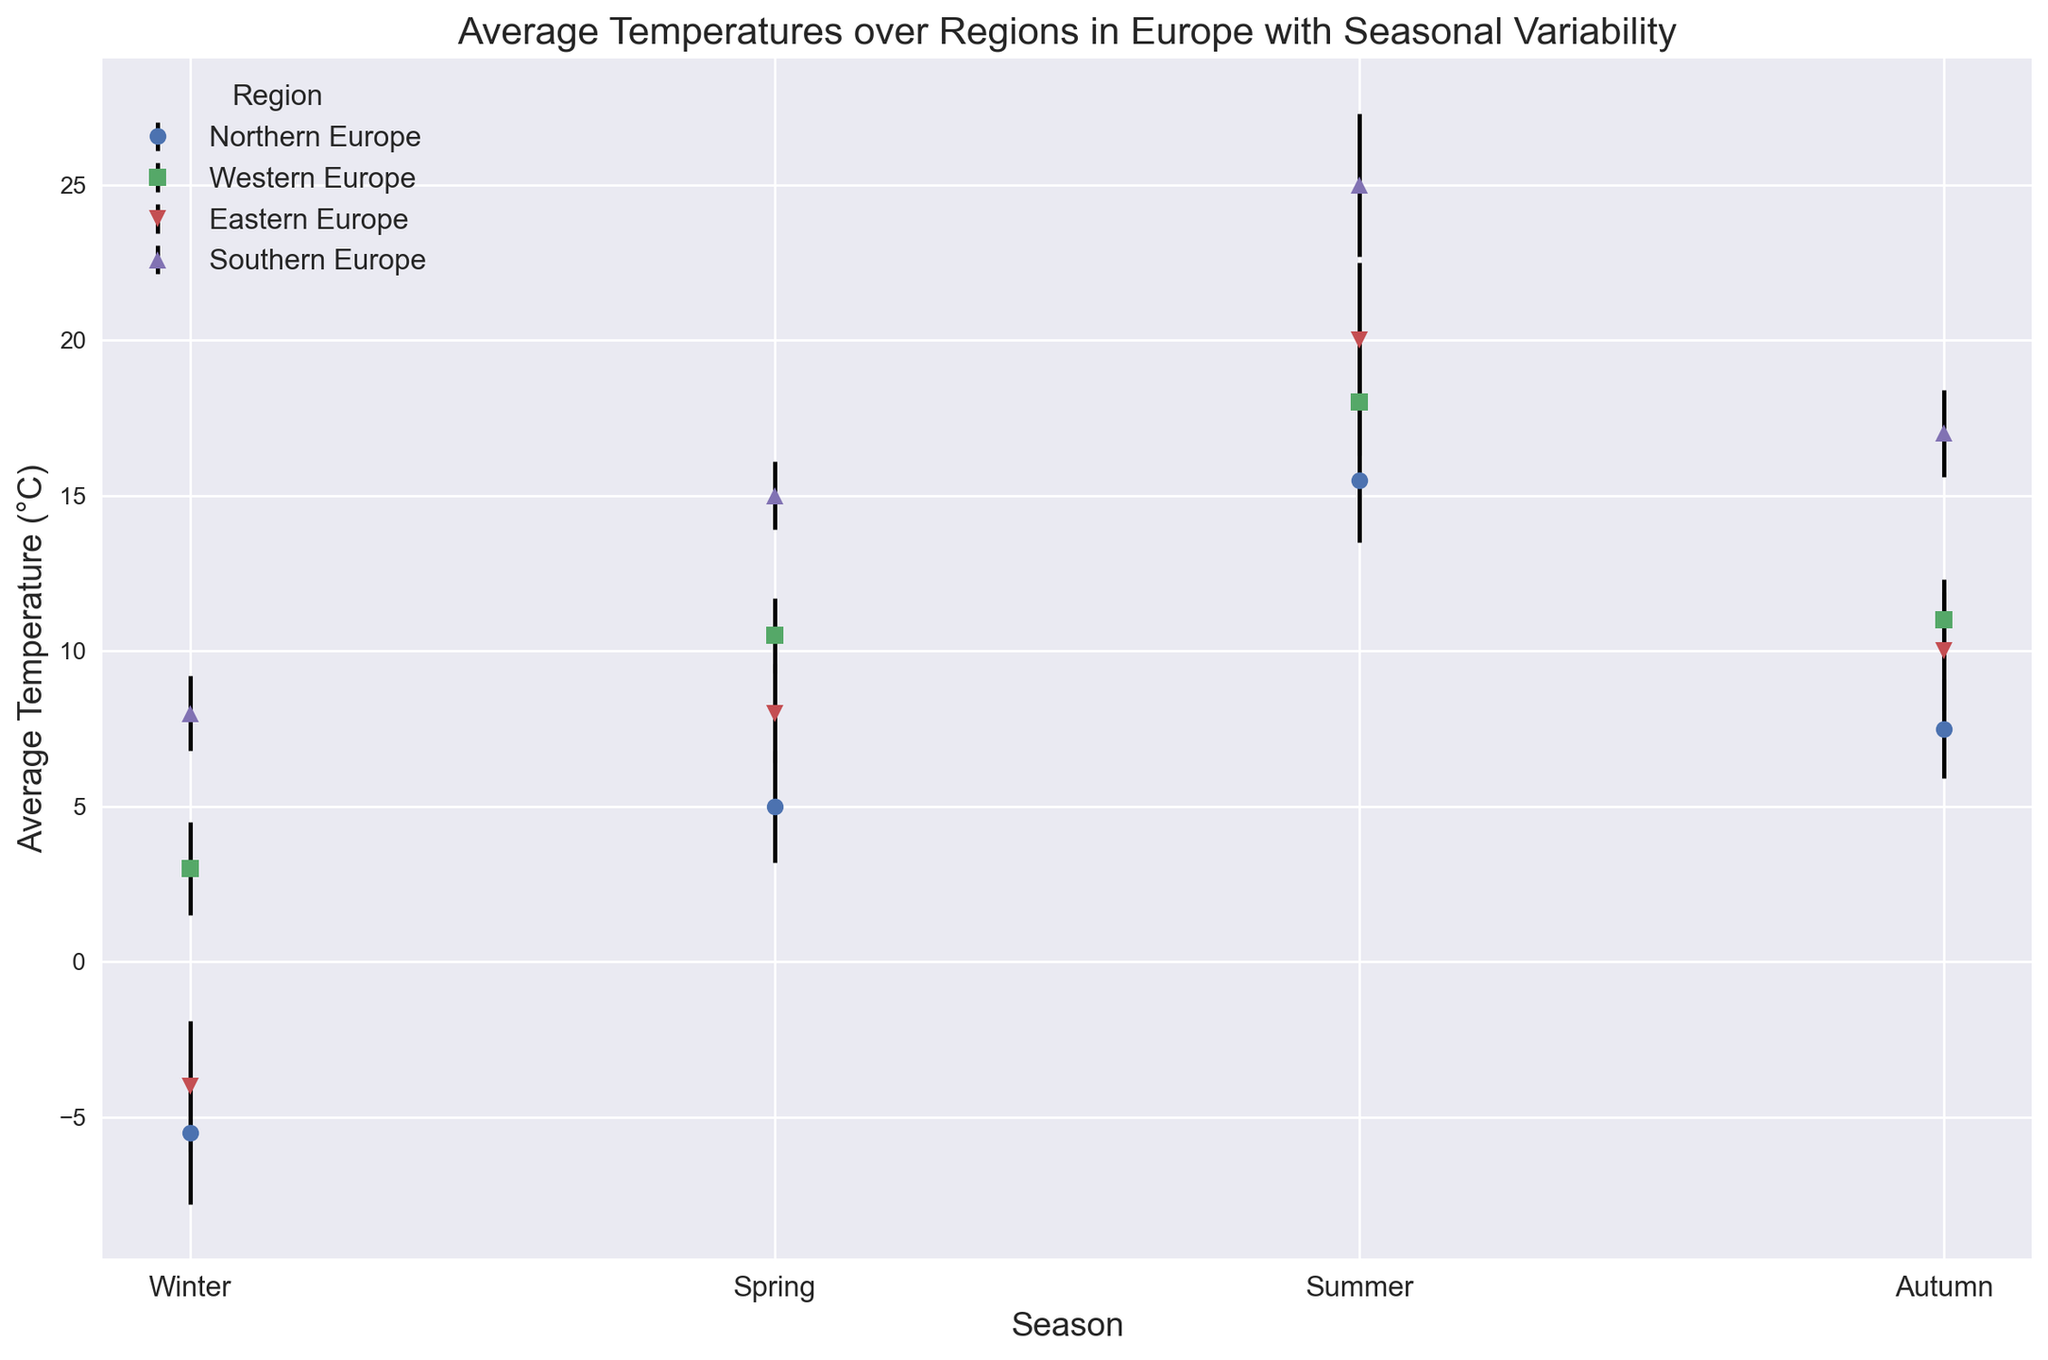Which region has the highest average temperature in Summer? Look at the markers representing Summer for each region and compare their heights. The highest marker corresponds to the highest average temperature. The red triangle for Southern Europe is highest.
Answer: Southern Europe In which season does Northern Europe experience the widest temperature variation? Analyze the error bars for Northern Europe in each season. The error bar in Winter is the longest.
Answer: Winter What is the average of the Spring temperatures for Western and Eastern Europe? Take the Spring temperatures for Western Europe (10.5) and Eastern Europe (8.0), then calculate (10.5 + 8.0) / 2.
Answer: 9.25 Which season shows the smallest variability in average temperature for Southern Europe? Look at the lengths of error bars for Southern Europe in each season. The shortest error bar is in Spring.
Answer: Spring Compare the average temperature in Autumn between Northern and Western Europe. Which is lower? Observe the Autumn markers for both Northern (green diamond) and Western Europe (blue square). The green diamond (Northern Europe) is lower.
Answer: Northern Europe What is the difference between the highest average temperature in any season and the lowest average temperature in any season? Identify the highest (Southern Europe in Summer, 25°C) and lowest average temperatures (Northern Europe in Winter, -5.5°C), then calculate 25 - (-5.5).
Answer: 30.5 Which region has the most consistent average temperature across all seasons, considering standard deviations? Check the lengths of error bars for all seasons in each region. Western Europe shows the smallest variation, as its error bars are consistently short.
Answer: Western Europe By how much does the Winter temperature in Eastern Europe differ from the Winter temperature in Southern Europe? Subtract the Winter temperature of Eastern Europe (-4.0) from Southern Europe (8.0).
Answer: 12 In which season is the variation in temperature the largest across all regions? Compare the lengths of error bars for all regions in each season. The error bars in Summer are the longest overall.
Answer: Summer 